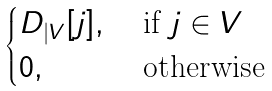Convert formula to latex. <formula><loc_0><loc_0><loc_500><loc_500>\begin{cases} D _ { | V } [ j ] , & \text { if } j \in V \\ 0 , & \text { otherwise} \end{cases}</formula> 